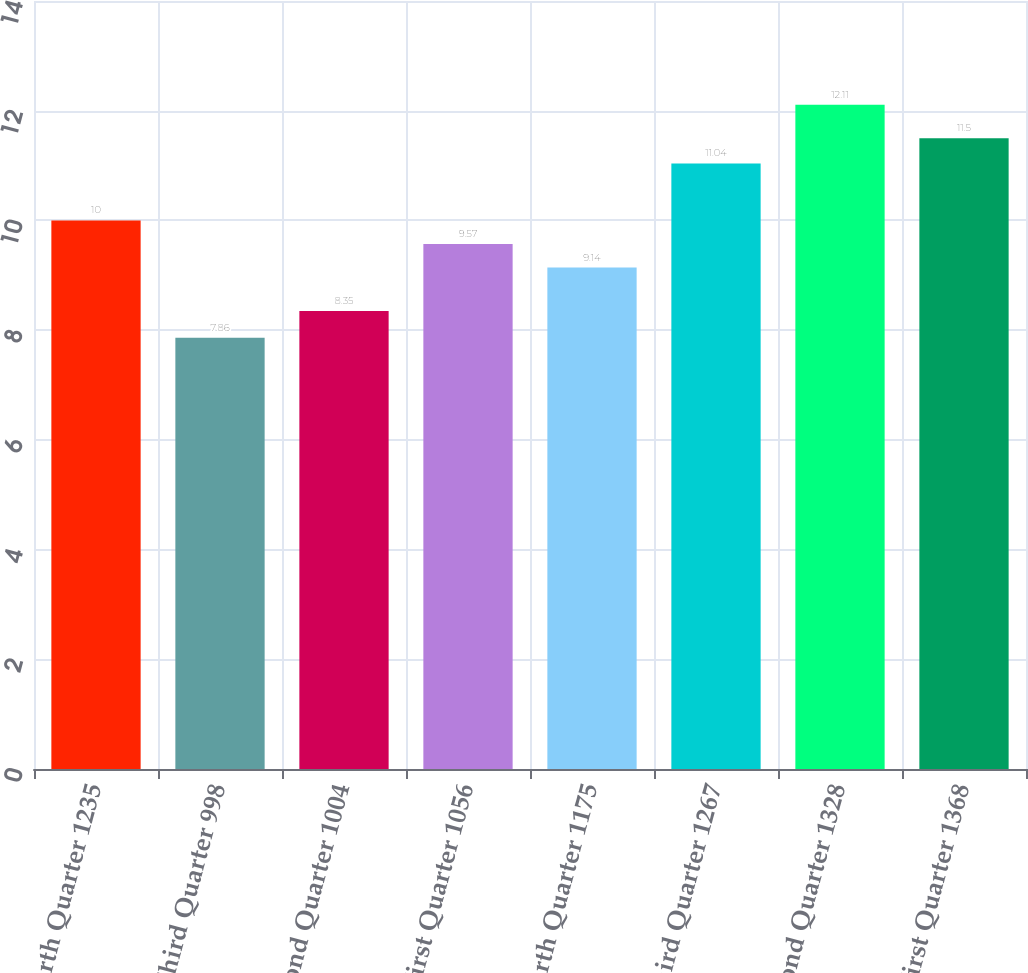<chart> <loc_0><loc_0><loc_500><loc_500><bar_chart><fcel>Fourth Quarter 1235<fcel>Third Quarter 998<fcel>Second Quarter 1004<fcel>First Quarter 1056<fcel>Fourth Quarter 1175<fcel>Third Quarter 1267<fcel>Second Quarter 1328<fcel>First Quarter 1368<nl><fcel>10<fcel>7.86<fcel>8.35<fcel>9.57<fcel>9.14<fcel>11.04<fcel>12.11<fcel>11.5<nl></chart> 